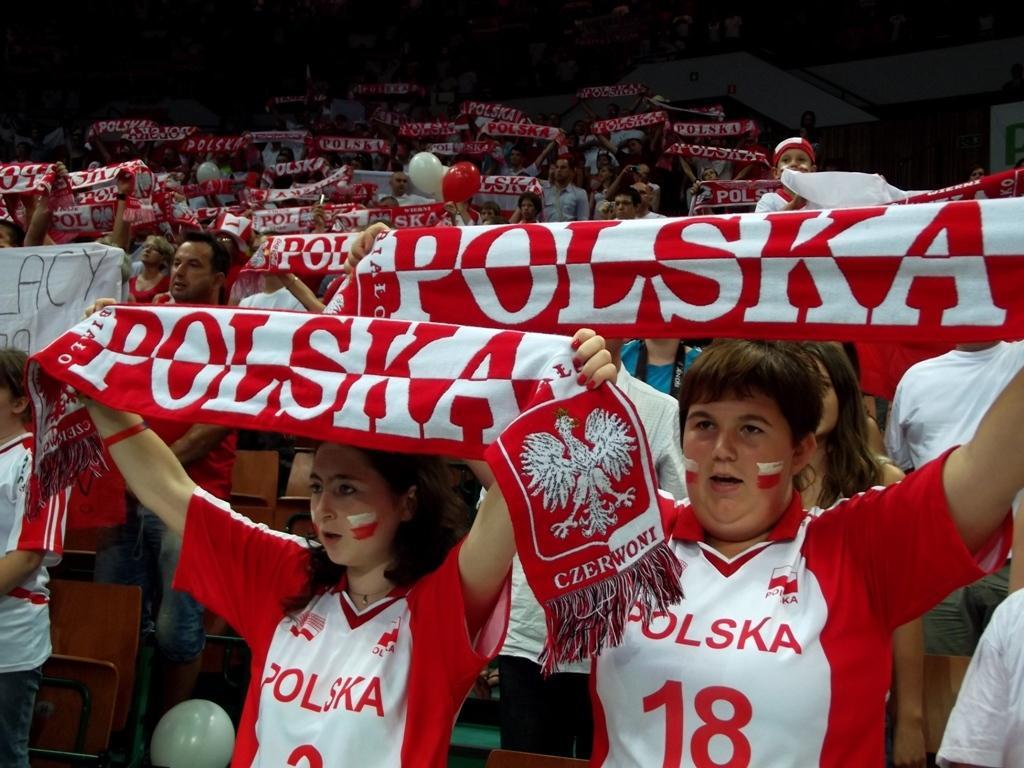How would you summarize this image in a sentence or two? In the picture I can see few persons wearing red and white color T-shirts are standing and holding a cloth which has something written on it. 